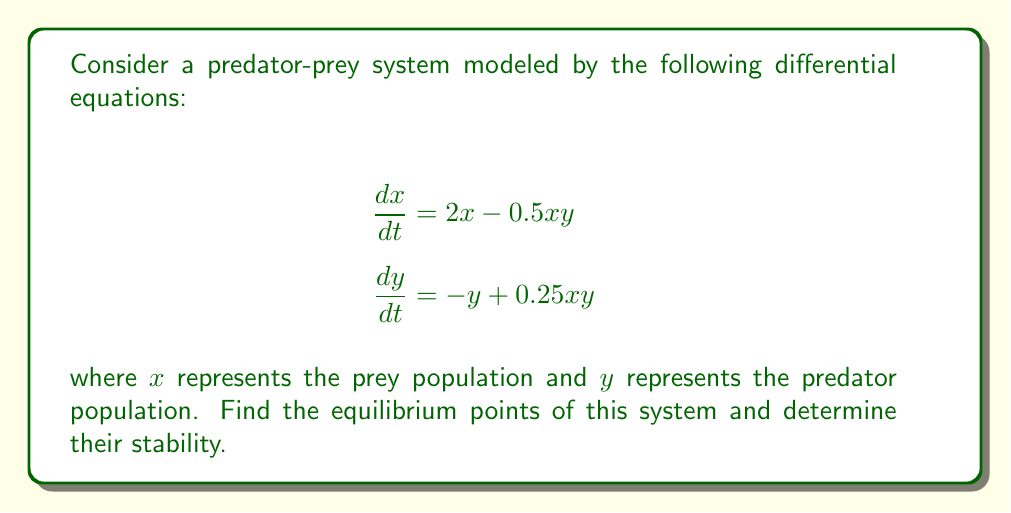Could you help me with this problem? 1) To find the equilibrium points, we set both equations equal to zero:

   $$2x - 0.5xy = 0$$
   $$-y + 0.25xy = 0$$

2) From the second equation:
   $$y(0.25x - 1) = 0$$
   This gives us $y = 0$ or $x = 4$

3) If $y = 0$, substituting into the first equation:
   $$2x = 0$$
   $$x = 0$$
   So one equilibrium point is $(0,0)$

4) If $x = 4$, substituting into the first equation:
   $$8 - 2y = 0$$
   $$y = 4$$
   So the other equilibrium point is $(4,4)$

5) To determine stability, we need to find the Jacobian matrix:
   $$J = \begin{bmatrix}
   2 - 0.5y & -0.5x \\
   0.25y & -1 + 0.25x
   \end{bmatrix}$$

6) For $(0,0)$:
   $$J_{(0,0)} = \begin{bmatrix}
   2 & 0 \\
   0 & -1
   \end{bmatrix}$$
   Eigenvalues are 2 and -1. Since one is positive, $(0,0)$ is unstable (saddle point).

7) For $(4,4)$:
   $$J_{(4,4)} = \begin{bmatrix}
   0 & -2 \\
   1 & 0
   \end{bmatrix}$$
   Eigenvalues are $\pm i\sqrt{2}$. Both are imaginary with zero real part, indicating a center (neutrally stable).
Answer: Equilibrium points: $(0,0)$ (unstable saddle point) and $(4,4)$ (neutrally stable center). 